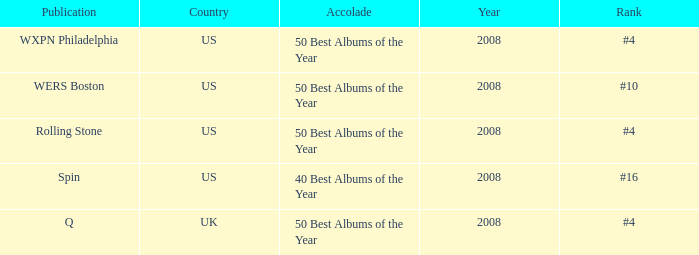Which year's rank was #4 when the country was the US? 2008, 2008. 